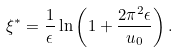<formula> <loc_0><loc_0><loc_500><loc_500>\xi ^ { * } = \frac { 1 } { \epsilon } \ln \left ( 1 + \frac { 2 \pi ^ { 2 } \epsilon } { u _ { 0 } } \right ) .</formula> 